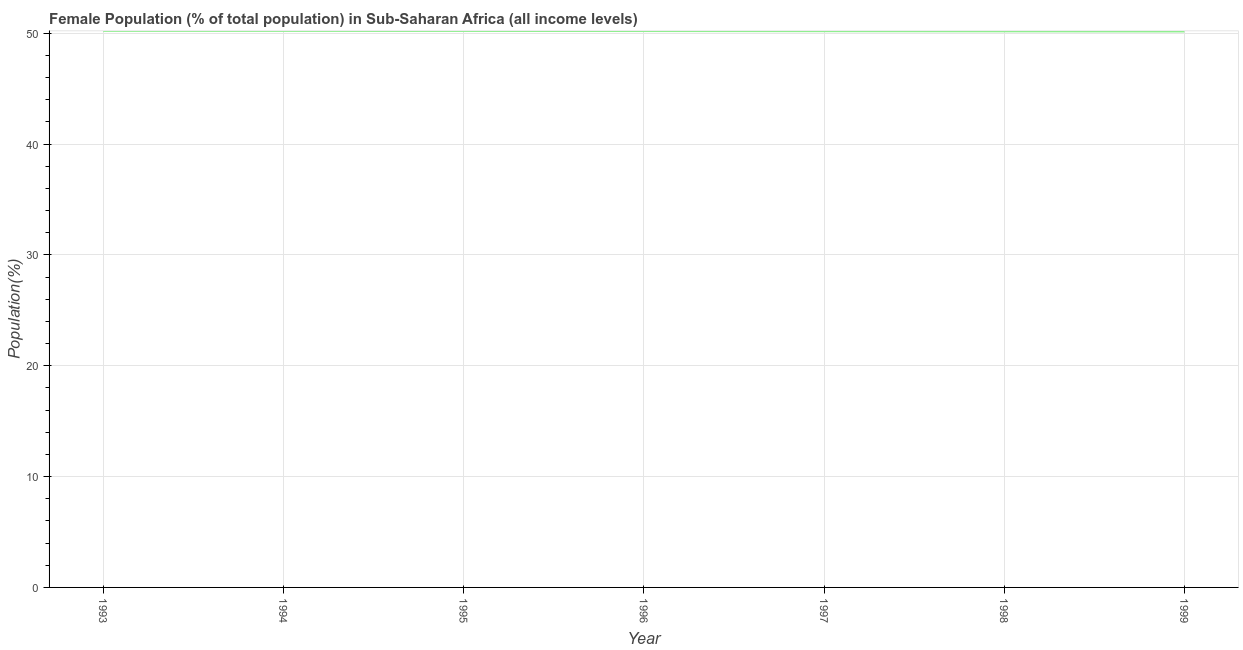What is the female population in 1995?
Ensure brevity in your answer.  50.21. Across all years, what is the maximum female population?
Provide a short and direct response. 50.22. Across all years, what is the minimum female population?
Your response must be concise. 50.16. In which year was the female population minimum?
Keep it short and to the point. 1999. What is the sum of the female population?
Your response must be concise. 351.38. What is the difference between the female population in 1996 and 1997?
Make the answer very short. 0.01. What is the average female population per year?
Your response must be concise. 50.2. What is the median female population?
Offer a very short reply. 50.2. In how many years, is the female population greater than 48 %?
Ensure brevity in your answer.  7. Do a majority of the years between 1994 and 1993 (inclusive) have female population greater than 24 %?
Your response must be concise. No. What is the ratio of the female population in 1994 to that in 1995?
Keep it short and to the point. 1. Is the difference between the female population in 1997 and 1999 greater than the difference between any two years?
Provide a short and direct response. No. What is the difference between the highest and the second highest female population?
Give a very brief answer. 0. What is the difference between the highest and the lowest female population?
Offer a very short reply. 0.06. Does the female population monotonically increase over the years?
Keep it short and to the point. No. How many lines are there?
Your response must be concise. 1. What is the difference between two consecutive major ticks on the Y-axis?
Keep it short and to the point. 10. Are the values on the major ticks of Y-axis written in scientific E-notation?
Provide a succinct answer. No. Does the graph contain any zero values?
Make the answer very short. No. Does the graph contain grids?
Your answer should be very brief. Yes. What is the title of the graph?
Keep it short and to the point. Female Population (% of total population) in Sub-Saharan Africa (all income levels). What is the label or title of the Y-axis?
Provide a succinct answer. Population(%). What is the Population(%) of 1993?
Make the answer very short. 50.22. What is the Population(%) in 1994?
Provide a short and direct response. 50.22. What is the Population(%) in 1995?
Offer a terse response. 50.21. What is the Population(%) of 1996?
Give a very brief answer. 50.2. What is the Population(%) of 1997?
Your answer should be compact. 50.19. What is the Population(%) of 1998?
Offer a terse response. 50.18. What is the Population(%) in 1999?
Provide a short and direct response. 50.16. What is the difference between the Population(%) in 1993 and 1994?
Provide a short and direct response. 0. What is the difference between the Population(%) in 1993 and 1995?
Ensure brevity in your answer.  0.01. What is the difference between the Population(%) in 1993 and 1996?
Your response must be concise. 0.02. What is the difference between the Population(%) in 1993 and 1997?
Your response must be concise. 0.03. What is the difference between the Population(%) in 1993 and 1998?
Give a very brief answer. 0.04. What is the difference between the Population(%) in 1993 and 1999?
Give a very brief answer. 0.06. What is the difference between the Population(%) in 1994 and 1995?
Give a very brief answer. 0.01. What is the difference between the Population(%) in 1994 and 1996?
Your response must be concise. 0.01. What is the difference between the Population(%) in 1994 and 1997?
Ensure brevity in your answer.  0.03. What is the difference between the Population(%) in 1994 and 1998?
Provide a short and direct response. 0.04. What is the difference between the Population(%) in 1994 and 1999?
Keep it short and to the point. 0.05. What is the difference between the Population(%) in 1995 and 1996?
Ensure brevity in your answer.  0.01. What is the difference between the Population(%) in 1995 and 1997?
Your response must be concise. 0.02. What is the difference between the Population(%) in 1995 and 1998?
Make the answer very short. 0.03. What is the difference between the Population(%) in 1995 and 1999?
Keep it short and to the point. 0.05. What is the difference between the Population(%) in 1996 and 1997?
Make the answer very short. 0.01. What is the difference between the Population(%) in 1996 and 1998?
Offer a very short reply. 0.03. What is the difference between the Population(%) in 1996 and 1999?
Provide a short and direct response. 0.04. What is the difference between the Population(%) in 1997 and 1998?
Keep it short and to the point. 0.01. What is the difference between the Population(%) in 1997 and 1999?
Keep it short and to the point. 0.03. What is the difference between the Population(%) in 1998 and 1999?
Make the answer very short. 0.01. What is the ratio of the Population(%) in 1993 to that in 1994?
Your answer should be compact. 1. What is the ratio of the Population(%) in 1993 to that in 1995?
Provide a short and direct response. 1. What is the ratio of the Population(%) in 1993 to that in 1997?
Your answer should be compact. 1. What is the ratio of the Population(%) in 1993 to that in 1998?
Offer a very short reply. 1. What is the ratio of the Population(%) in 1994 to that in 1998?
Your response must be concise. 1. What is the ratio of the Population(%) in 1994 to that in 1999?
Offer a very short reply. 1. What is the ratio of the Population(%) in 1995 to that in 1998?
Your answer should be compact. 1. What is the ratio of the Population(%) in 1995 to that in 1999?
Provide a short and direct response. 1. What is the ratio of the Population(%) in 1996 to that in 1997?
Provide a short and direct response. 1. What is the ratio of the Population(%) in 1996 to that in 1998?
Offer a terse response. 1. What is the ratio of the Population(%) in 1997 to that in 1998?
Make the answer very short. 1. What is the ratio of the Population(%) in 1998 to that in 1999?
Your response must be concise. 1. 